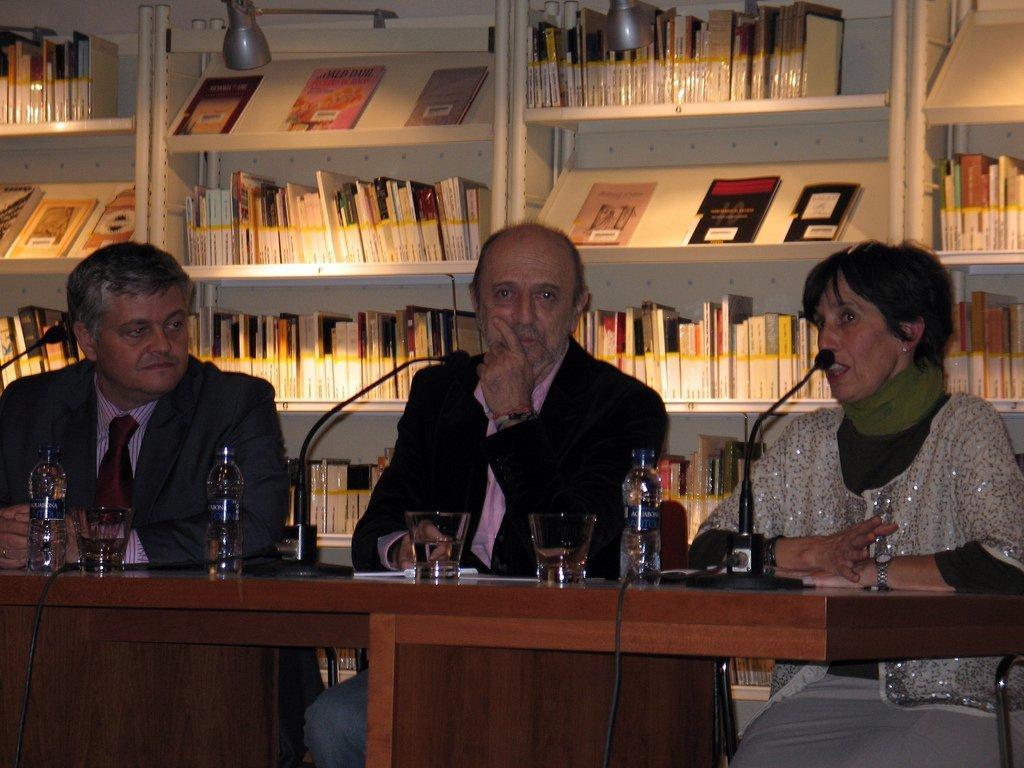Please provide a concise description of this image. In this image we can see three persons sitting. There is a table with glasses, bottles, mics and some other things. In the back there is a cupboard with racks. In that there are books. Also there are lights. 